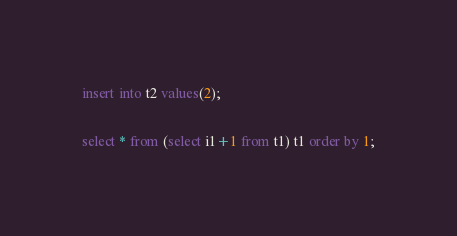Convert code to text. <code><loc_0><loc_0><loc_500><loc_500><_SQL_>insert into t2 values(2);

select * from (select i1+1 from t1) t1 order by 1;
</code> 